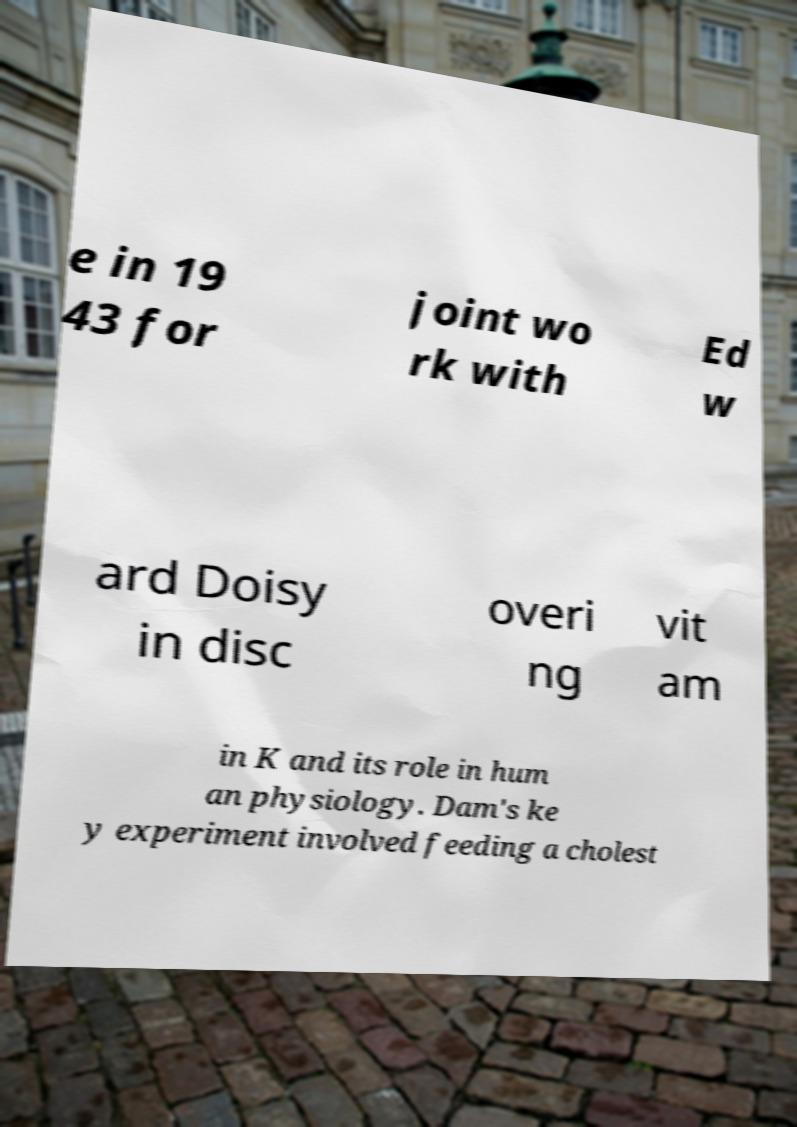Please identify and transcribe the text found in this image. e in 19 43 for joint wo rk with Ed w ard Doisy in disc overi ng vit am in K and its role in hum an physiology. Dam's ke y experiment involved feeding a cholest 